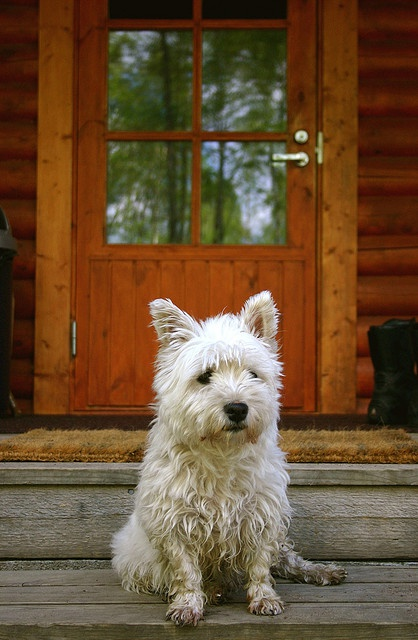Describe the objects in this image and their specific colors. I can see a dog in black, darkgray, lightgray, and gray tones in this image. 